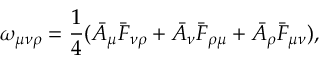<formula> <loc_0><loc_0><loc_500><loc_500>\omega _ { \mu \nu \rho } = \frac { 1 } { 4 } ( \bar { A } _ { \mu } \bar { F } _ { \nu \rho } + \bar { A } _ { \nu } \bar { F } _ { \rho \mu } + \bar { A } _ { \rho } \bar { F } _ { \mu \nu } ) ,</formula> 